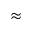Convert formula to latex. <formula><loc_0><loc_0><loc_500><loc_500>\approx</formula> 